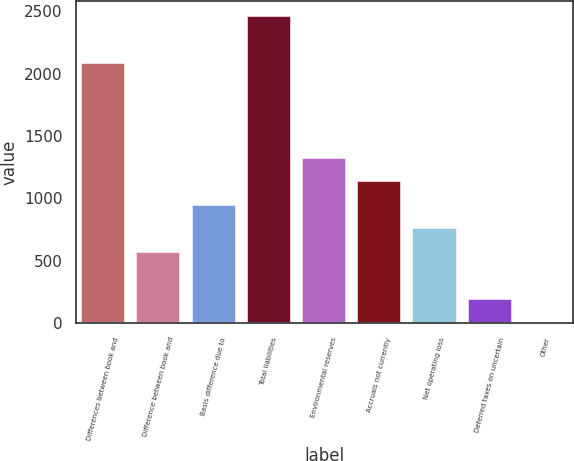<chart> <loc_0><loc_0><loc_500><loc_500><bar_chart><fcel>Differences between book and<fcel>Difference between book and<fcel>Basis difference due to<fcel>Total liabilities<fcel>Environmental reserves<fcel>Accruals not currently<fcel>Net operating loss<fcel>Deferred taxes on uncertain<fcel>Other<nl><fcel>2082.02<fcel>571.46<fcel>949.1<fcel>2459.66<fcel>1326.74<fcel>1137.92<fcel>760.28<fcel>193.82<fcel>5<nl></chart> 